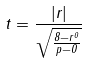<formula> <loc_0><loc_0><loc_500><loc_500>t = \frac { | r | } { \sqrt { \frac { 8 - r ^ { 0 } } { p - 0 } } }</formula> 